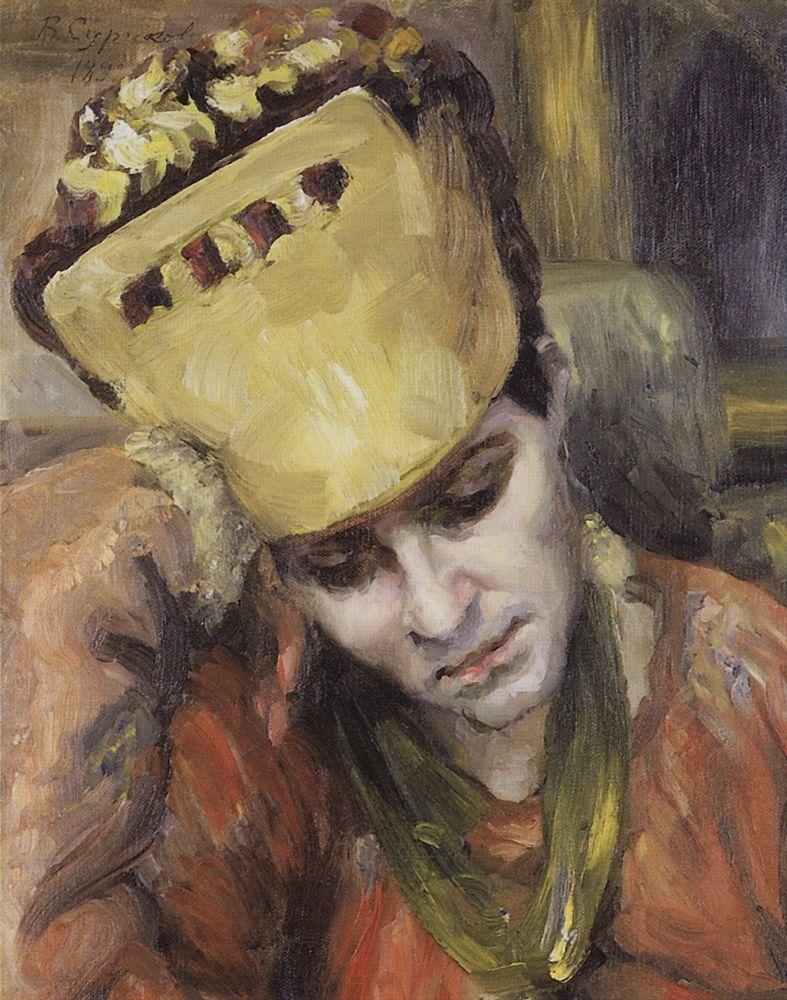Imagine the story behind this painting. What could the woman be thinking about? The story behind this painting could be one of love and longing. Perhaps the woman is reminiscing about a lost love or contemplating the choices she has made in her life. The vibrant hat with its floral embellishments might symbolize the beauty and vibrancy of her past, contrasting with the somber expression on her face as she reflects on her memories. It's a moment frozen in time, capturing the complexity of her emotions and the depth of her inner world. 